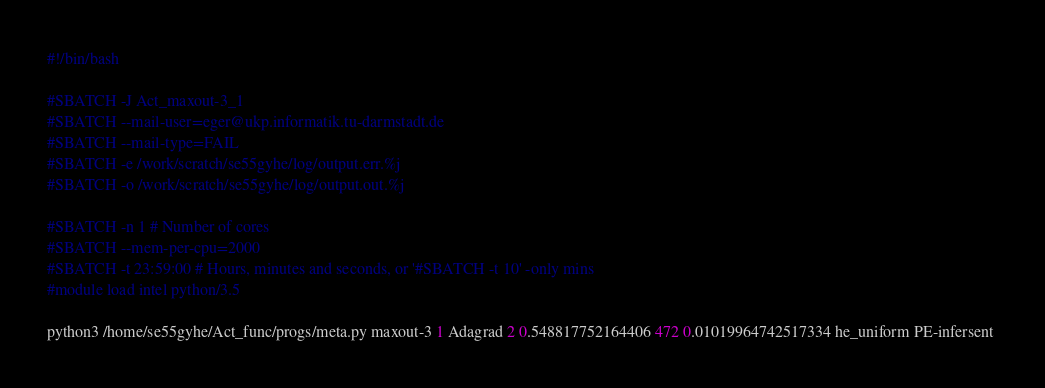Convert code to text. <code><loc_0><loc_0><loc_500><loc_500><_Bash_>#!/bin/bash
 
#SBATCH -J Act_maxout-3_1
#SBATCH --mail-user=eger@ukp.informatik.tu-darmstadt.de
#SBATCH --mail-type=FAIL
#SBATCH -e /work/scratch/se55gyhe/log/output.err.%j
#SBATCH -o /work/scratch/se55gyhe/log/output.out.%j

#SBATCH -n 1 # Number of cores
#SBATCH --mem-per-cpu=2000
#SBATCH -t 23:59:00 # Hours, minutes and seconds, or '#SBATCH -t 10' -only mins
#module load intel python/3.5

python3 /home/se55gyhe/Act_func/progs/meta.py maxout-3 1 Adagrad 2 0.548817752164406 472 0.01019964742517334 he_uniform PE-infersent 

</code> 